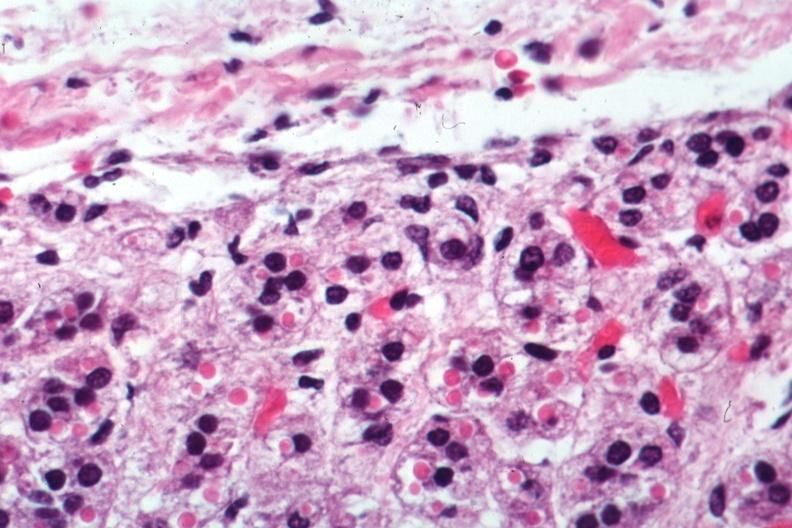what does this image show?
Answer the question using a single word or phrase. Excellent example 